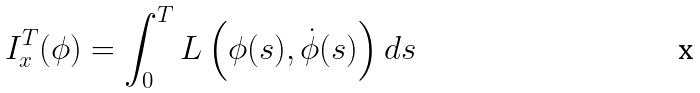Convert formula to latex. <formula><loc_0><loc_0><loc_500><loc_500>I _ { x } ^ { T } ( \phi ) = \int _ { 0 } ^ { T } L \left ( \phi ( s ) , \dot { \phi } ( s ) \right ) d s</formula> 